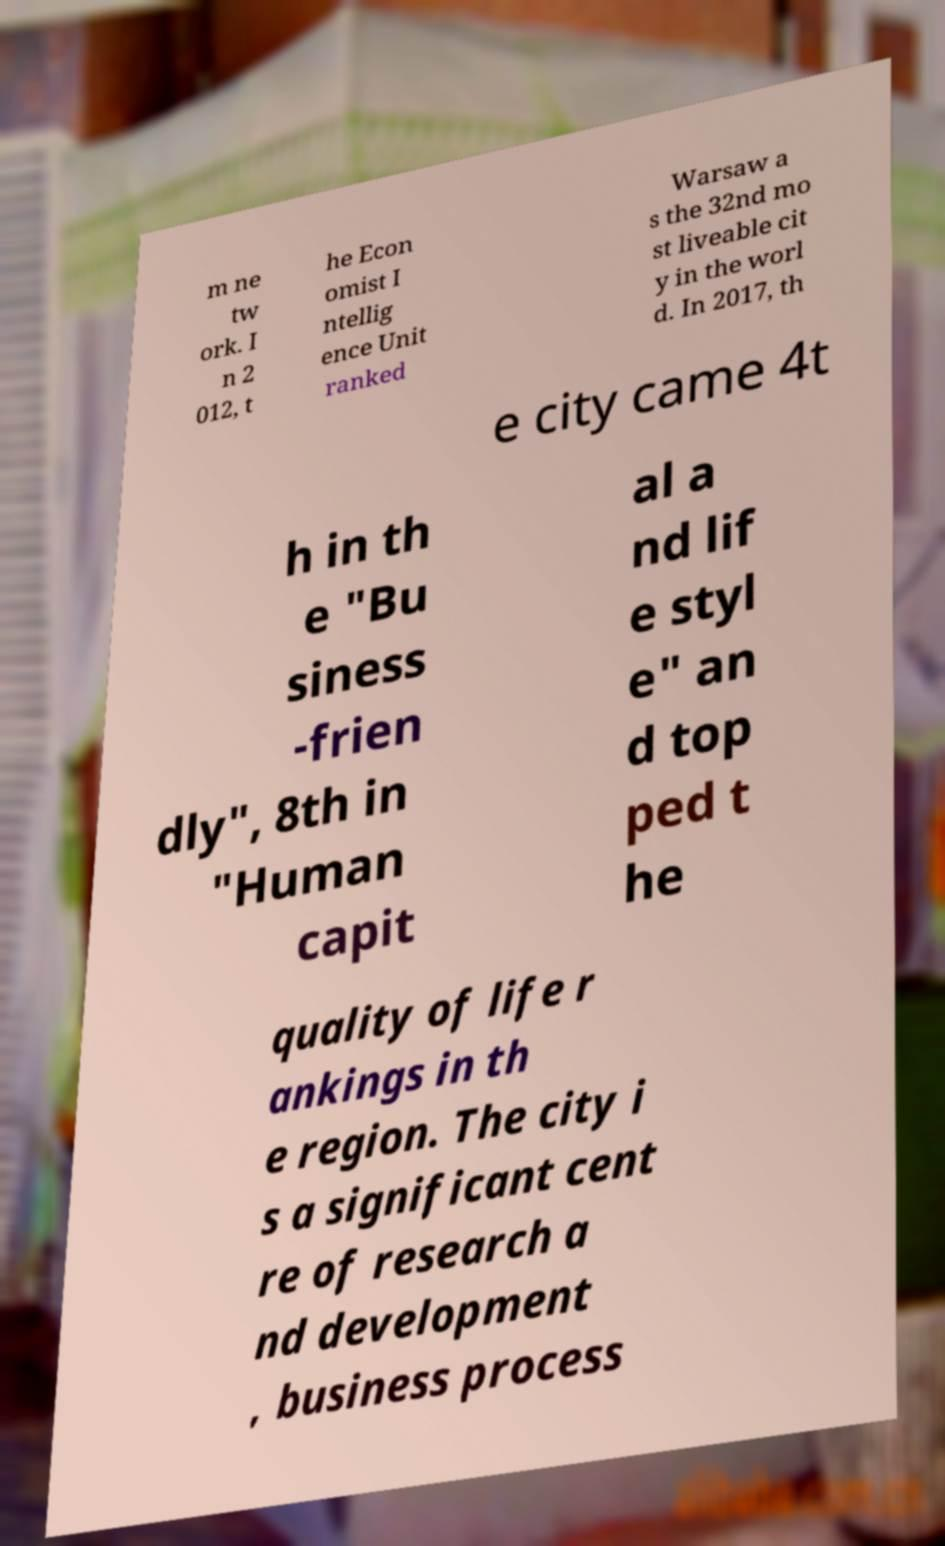Can you accurately transcribe the text from the provided image for me? m ne tw ork. I n 2 012, t he Econ omist I ntellig ence Unit ranked Warsaw a s the 32nd mo st liveable cit y in the worl d. In 2017, th e city came 4t h in th e "Bu siness -frien dly", 8th in "Human capit al a nd lif e styl e" an d top ped t he quality of life r ankings in th e region. The city i s a significant cent re of research a nd development , business process 